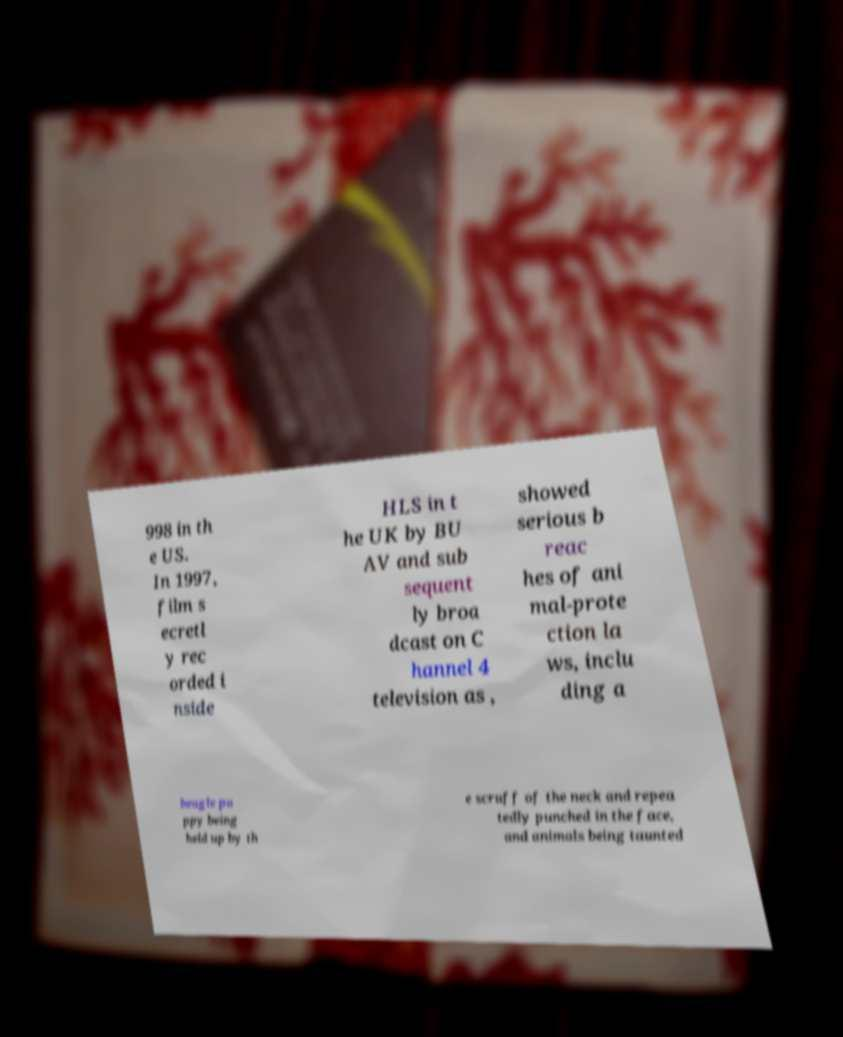What messages or text are displayed in this image? I need them in a readable, typed format. 998 in th e US. In 1997, film s ecretl y rec orded i nside HLS in t he UK by BU AV and sub sequent ly broa dcast on C hannel 4 television as , showed serious b reac hes of ani mal-prote ction la ws, inclu ding a beagle pu ppy being held up by th e scruff of the neck and repea tedly punched in the face, and animals being taunted 